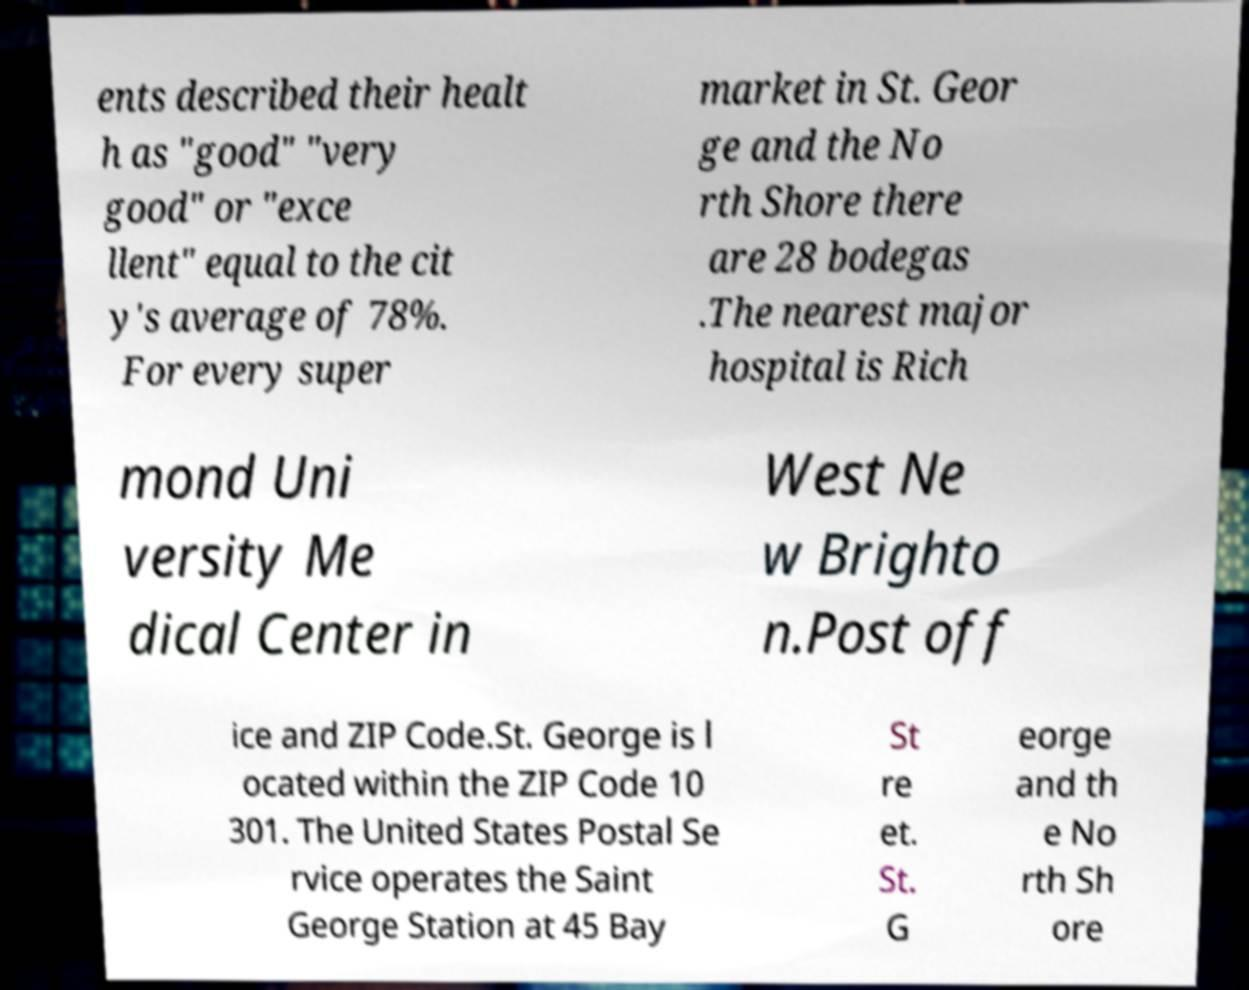Please read and relay the text visible in this image. What does it say? ents described their healt h as "good" "very good" or "exce llent" equal to the cit y's average of 78%. For every super market in St. Geor ge and the No rth Shore there are 28 bodegas .The nearest major hospital is Rich mond Uni versity Me dical Center in West Ne w Brighto n.Post off ice and ZIP Code.St. George is l ocated within the ZIP Code 10 301. The United States Postal Se rvice operates the Saint George Station at 45 Bay St re et. St. G eorge and th e No rth Sh ore 